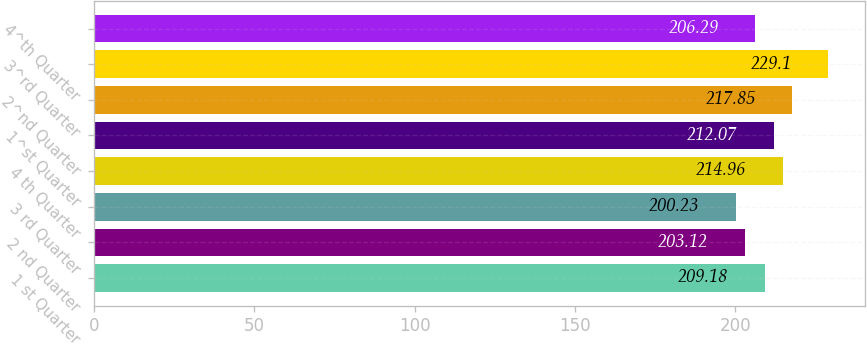<chart> <loc_0><loc_0><loc_500><loc_500><bar_chart><fcel>1 st Quarter<fcel>2 nd Quarter<fcel>3 rd Quarter<fcel>4 th Quarter<fcel>1^st Quarter<fcel>2^nd Quarter<fcel>3^rd Quarter<fcel>4^th Quarter<nl><fcel>209.18<fcel>203.12<fcel>200.23<fcel>214.96<fcel>212.07<fcel>217.85<fcel>229.1<fcel>206.29<nl></chart> 